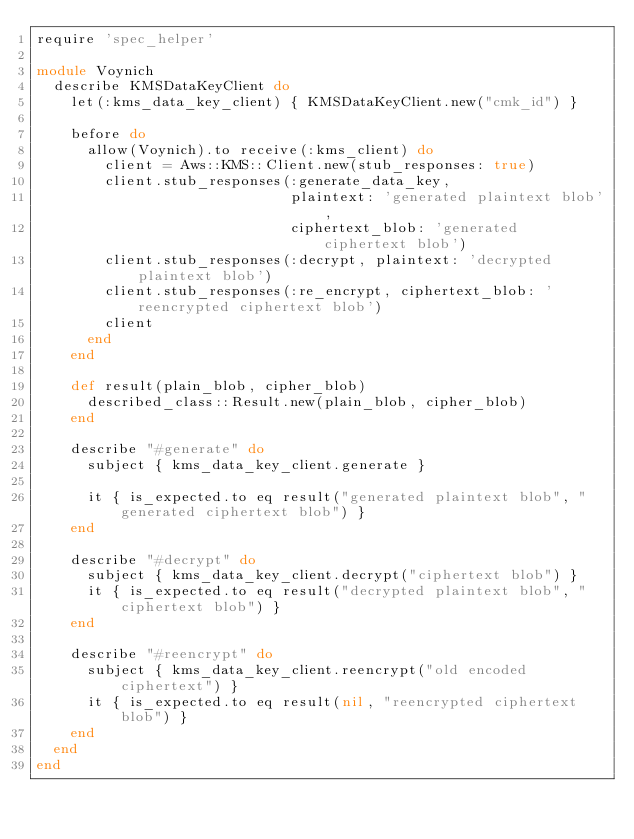<code> <loc_0><loc_0><loc_500><loc_500><_Ruby_>require 'spec_helper'

module Voynich
  describe KMSDataKeyClient do
    let(:kms_data_key_client) { KMSDataKeyClient.new("cmk_id") }

    before do
      allow(Voynich).to receive(:kms_client) do
        client = Aws::KMS::Client.new(stub_responses: true)
        client.stub_responses(:generate_data_key,
                              plaintext: 'generated plaintext blob',
                              ciphertext_blob: 'generated ciphertext blob')
        client.stub_responses(:decrypt, plaintext: 'decrypted plaintext blob')
        client.stub_responses(:re_encrypt, ciphertext_blob: 'reencrypted ciphertext blob')
        client
      end
    end

    def result(plain_blob, cipher_blob)
      described_class::Result.new(plain_blob, cipher_blob)
    end

    describe "#generate" do
      subject { kms_data_key_client.generate }

      it { is_expected.to eq result("generated plaintext blob", "generated ciphertext blob") }
    end

    describe "#decrypt" do
      subject { kms_data_key_client.decrypt("ciphertext blob") }
      it { is_expected.to eq result("decrypted plaintext blob", "ciphertext blob") }
    end

    describe "#reencrypt" do
      subject { kms_data_key_client.reencrypt("old encoded ciphertext") }
      it { is_expected.to eq result(nil, "reencrypted ciphertext blob") }
    end
  end
end
</code> 